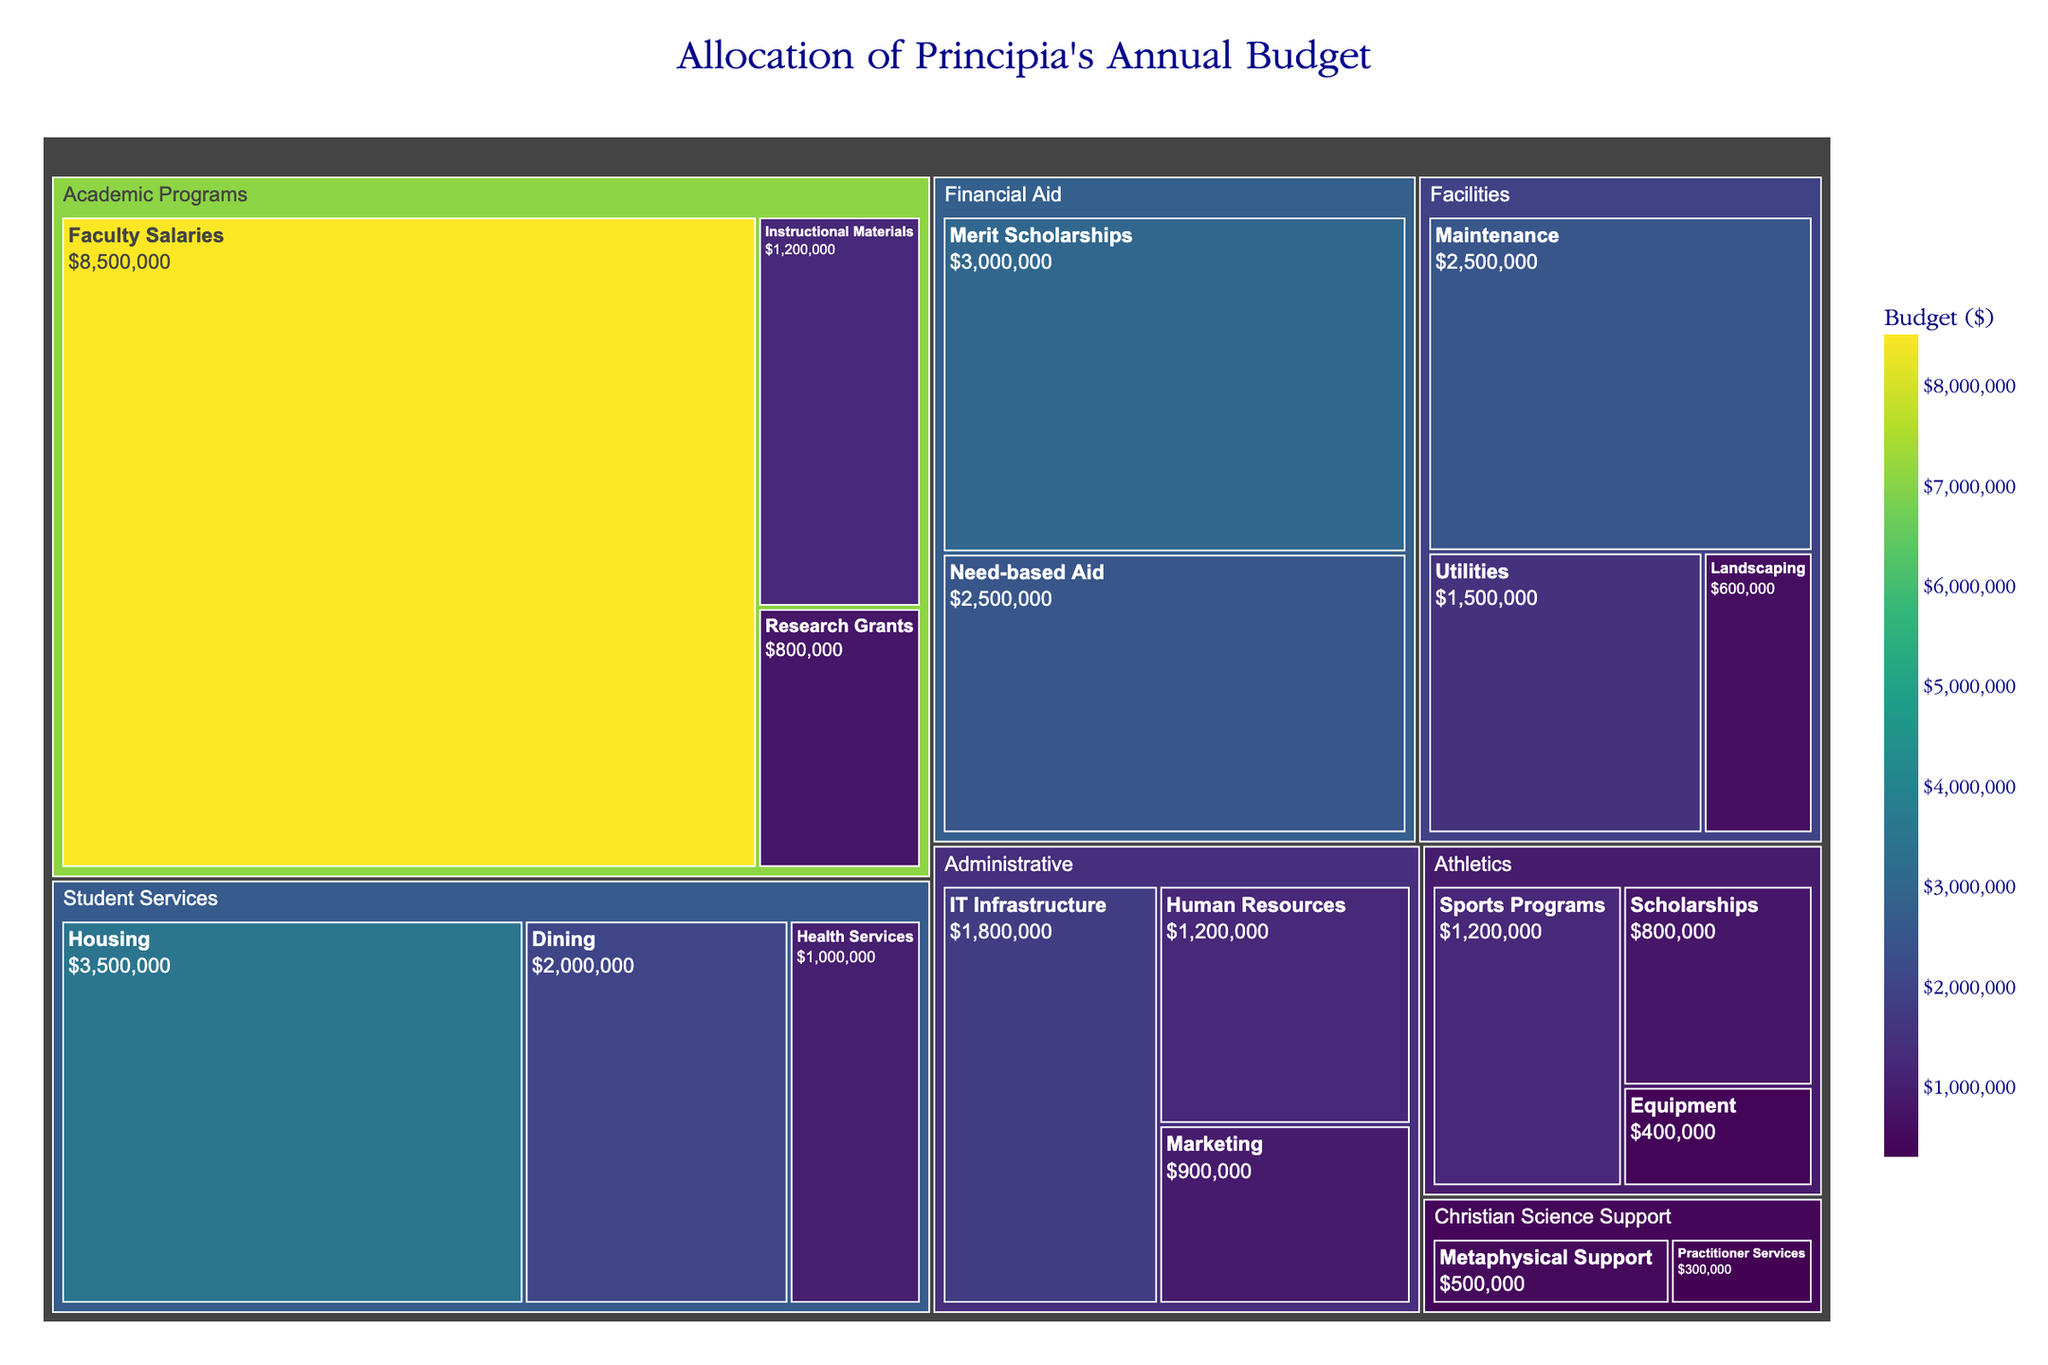What's the title of the figure? The title is usually located at the top of the figure. By observing the top section of the treemap, we can identify the title.
Answer: Allocation of Principia's Annual Budget Which category has the largest allocation of the budget? To find the category with the largest allocation, look for the largest section of the treemap. The size of each category's section represents its budget allocation.
Answer: Academic Programs What is the total budget allocated to Student Services? Add up the values for Housing, Dining, and Health Services within the Student Services category. 3500000 (Housing) + 2000000 (Dining) + 1000000 (Health Services) = 6500000
Answer: $6,500,000 Which subcategory within the Administrative category has the smallest allocation? Within the Administrative section of the treemap, compare the sizes of IT Infrastructure, Human Resources, and Marketing. The smallest value corresponds to Marketing.
Answer: Marketing How does the budget for Merit Scholarships compare to Need-based Aid? Compare the sections labeled Merit Scholarships and Need-based Aid in the Financial Aid category. The values show that Merit Scholarships are allocated 3,000,000 and Need-based Aid is 2,500,000.
Answer: Merit Scholarships have a higher allocation What is the combined budget for all Athletics subcategories? Add the values allocated to Sports Programs, Equipment, and Scholarships within the Athletics category. 1200000 (Sports Programs) + 400000 (Equipment) + 800000 (Scholarships) = 2400000
Answer: $2,400,000 Which category has more funding: Facilities or Christian Science Support? Compare the combined sizes of the Facilities and Christian Science Support sections. Facilities total (2500000 + 1500000 + 600000) = 4600000 and Christian Science Support total (500000 + 300000) = 800000.
Answer: Facilities What is the average budget for subcategories in Academic Programs? Sum the values in Academic Programs: 8500000 (Faculty Salaries) + 1200000 (Instructional Materials) + 800000 (Research Grants) = 10500000. There are 3 subcategories, so divide by 3: 10500000 / 3 = 3500000.
Answer: $3,500,000 How does the budget for IT Infrastructure compare to Faculty Salaries? Compare the sections labeled IT Infrastructure in Administrative and Faculty Salaries in Academic Programs. The values show that IT Infrastructure is 1,800,000 and Faculty Salaries are 8,500,000.
Answer: Faculty Salaries have a higher allocation 